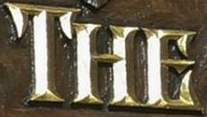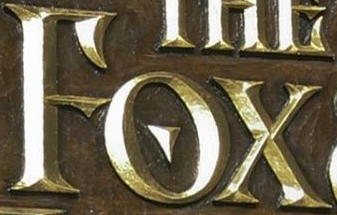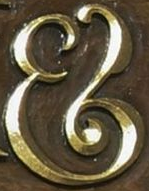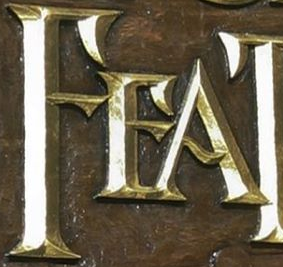Identify the words shown in these images in order, separated by a semicolon. THE; FOX; &; FEA 